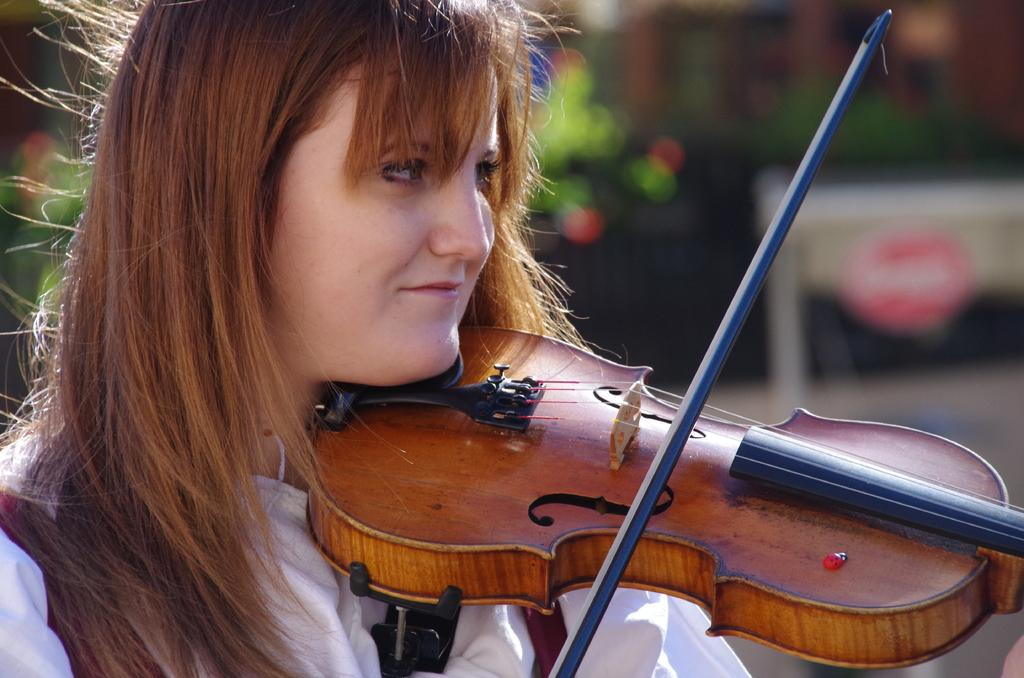Who is the main subject in the image? There is a lady in the image. What is the lady holding in her hand? The lady is holding a guitar in her hand. Can you describe the background of the image? The background of the image is blurry. What type of sock is the lady wearing on her head in the image? There is no sock present on the lady's head in the image. What kind of cracker is the lady eating while playing the guitar in the image? There is no cracker present in the image; the lady is holding a guitar. 